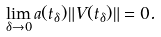Convert formula to latex. <formula><loc_0><loc_0><loc_500><loc_500>\lim _ { \delta \to 0 } a ( t _ { \delta } ) \| V ( t _ { \delta } ) \| = 0 .</formula> 